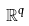Convert formula to latex. <formula><loc_0><loc_0><loc_500><loc_500>\mathbb { R } ^ { q }</formula> 